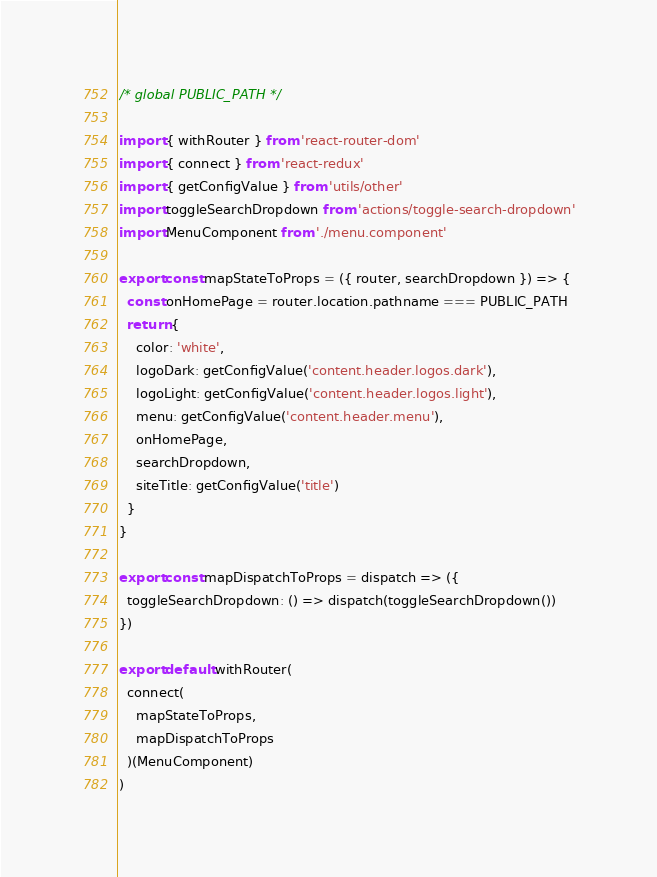<code> <loc_0><loc_0><loc_500><loc_500><_JavaScript_>/* global PUBLIC_PATH */

import { withRouter } from 'react-router-dom'
import { connect } from 'react-redux'
import { getConfigValue } from 'utils/other'
import toggleSearchDropdown from 'actions/toggle-search-dropdown'
import MenuComponent from './menu.component'

export const mapStateToProps = ({ router, searchDropdown }) => {
  const onHomePage = router.location.pathname === PUBLIC_PATH
  return {
    color: 'white',
    logoDark: getConfigValue('content.header.logos.dark'),
    logoLight: getConfigValue('content.header.logos.light'),
    menu: getConfigValue('content.header.menu'),
    onHomePage,
    searchDropdown,
    siteTitle: getConfigValue('title')
  }
}

export const mapDispatchToProps = dispatch => ({
  toggleSearchDropdown: () => dispatch(toggleSearchDropdown())
})

export default withRouter(
  connect(
    mapStateToProps,
    mapDispatchToProps
  )(MenuComponent)
)
</code> 